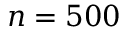<formula> <loc_0><loc_0><loc_500><loc_500>n = 5 0 0</formula> 